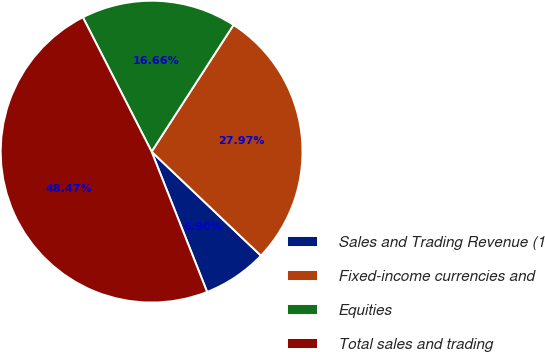<chart> <loc_0><loc_0><loc_500><loc_500><pie_chart><fcel>Sales and Trading Revenue (1<fcel>Fixed-income currencies and<fcel>Equities<fcel>Total sales and trading<nl><fcel>6.9%<fcel>27.97%<fcel>16.66%<fcel>48.47%<nl></chart> 